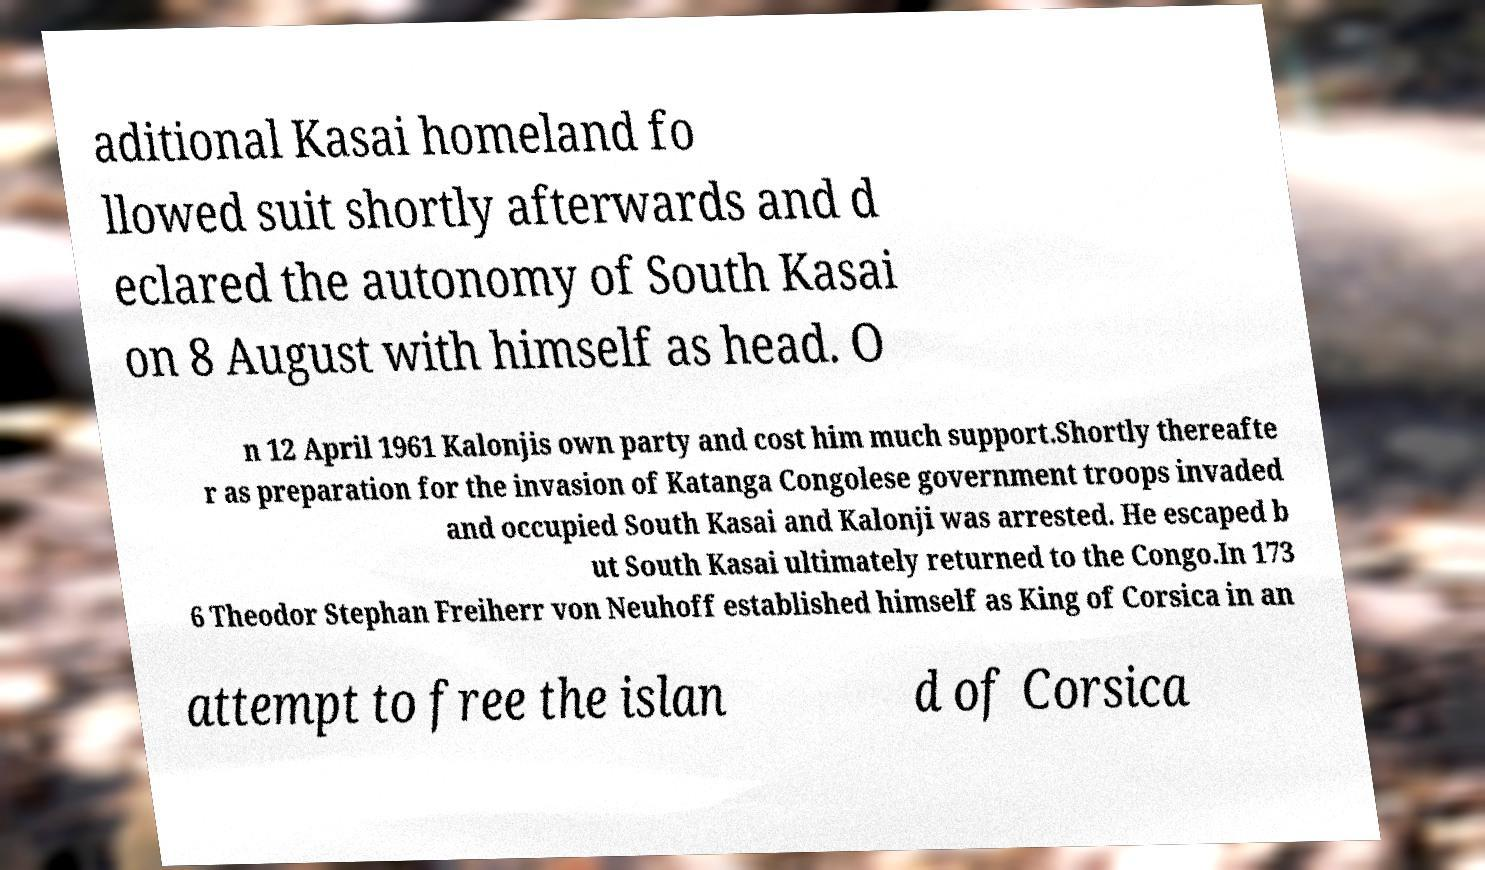Could you assist in decoding the text presented in this image and type it out clearly? aditional Kasai homeland fo llowed suit shortly afterwards and d eclared the autonomy of South Kasai on 8 August with himself as head. O n 12 April 1961 Kalonjis own party and cost him much support.Shortly thereafte r as preparation for the invasion of Katanga Congolese government troops invaded and occupied South Kasai and Kalonji was arrested. He escaped b ut South Kasai ultimately returned to the Congo.In 173 6 Theodor Stephan Freiherr von Neuhoff established himself as King of Corsica in an attempt to free the islan d of Corsica 